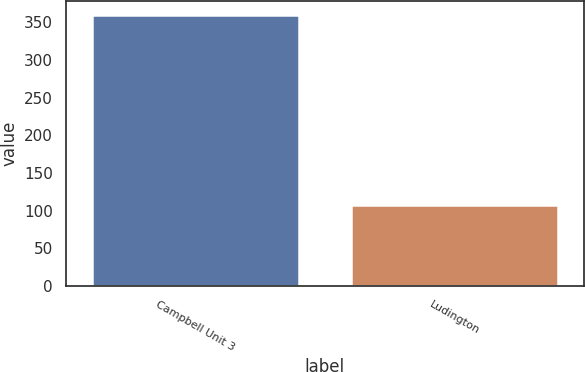Convert chart. <chart><loc_0><loc_0><loc_500><loc_500><bar_chart><fcel>Campbell Unit 3<fcel>Ludington<nl><fcel>360<fcel>107<nl></chart> 